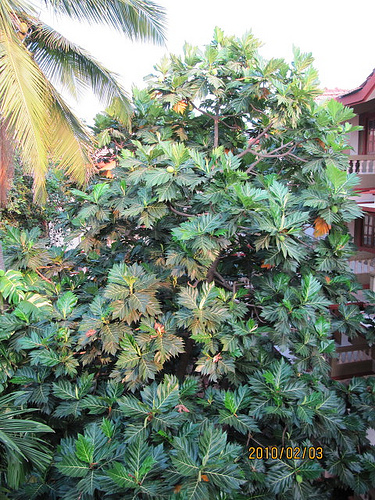<image>
Is there a tree behind the house? No. The tree is not behind the house. From this viewpoint, the tree appears to be positioned elsewhere in the scene. 